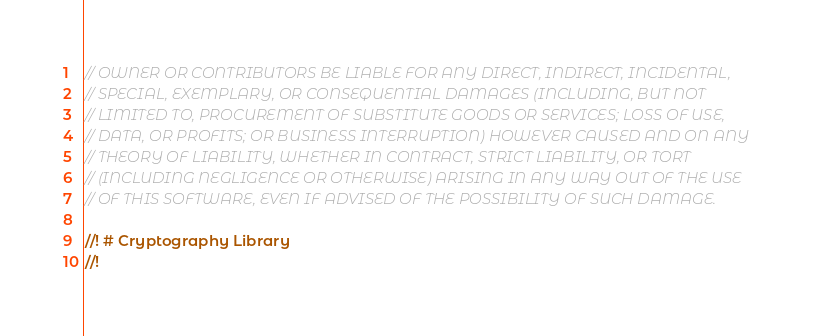Convert code to text. <code><loc_0><loc_0><loc_500><loc_500><_Rust_>// OWNER OR CONTRIBUTORS BE LIABLE FOR ANY DIRECT, INDIRECT, INCIDENTAL,
// SPECIAL, EXEMPLARY, OR CONSEQUENTIAL DAMAGES (INCLUDING, BUT NOT
// LIMITED TO, PROCUREMENT OF SUBSTITUTE GOODS OR SERVICES; LOSS OF USE,
// DATA, OR PROFITS; OR BUSINESS INTERRUPTION) HOWEVER CAUSED AND ON ANY
// THEORY OF LIABILITY, WHETHER IN CONTRACT, STRICT LIABILITY, OR TORT
// (INCLUDING NEGLIGENCE OR OTHERWISE) ARISING IN ANY WAY OUT OF THE USE
// OF THIS SOFTWARE, EVEN IF ADVISED OF THE POSSIBILITY OF SUCH DAMAGE.

//! # Cryptography Library
//!</code> 